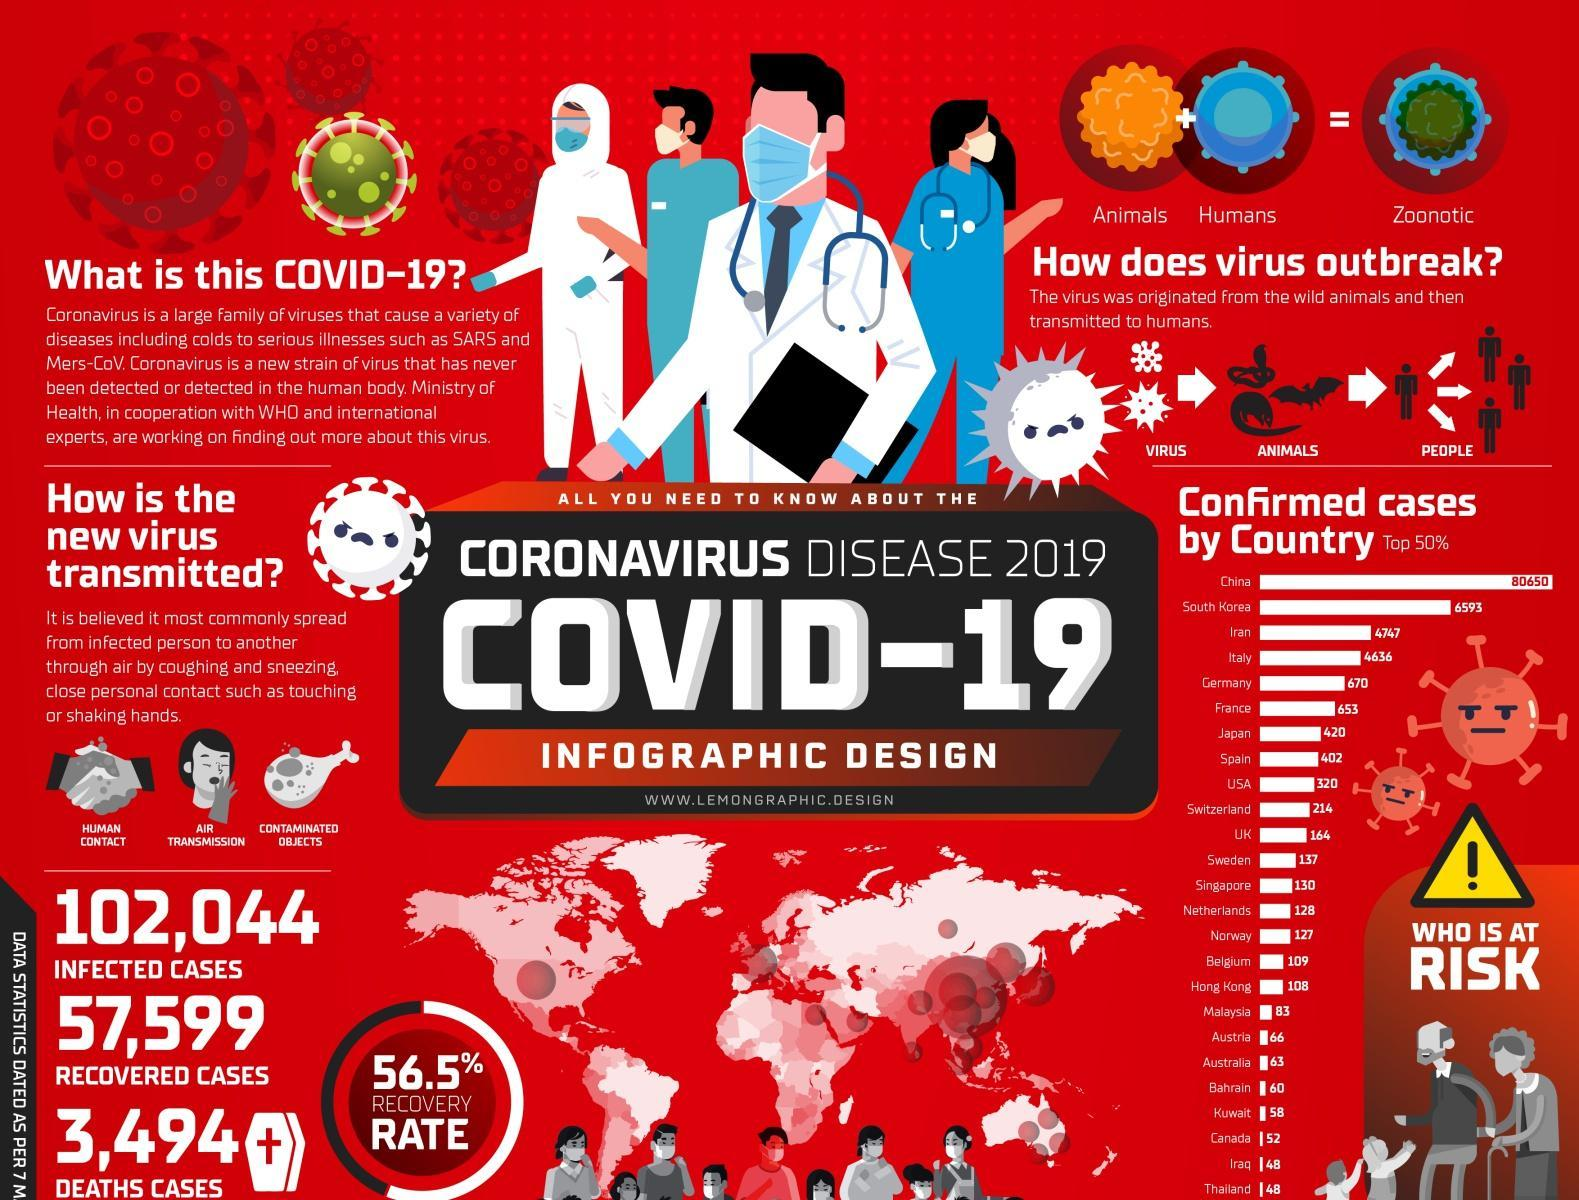What is the number of death cases?
Answer the question with a short phrase. 3,494 What is the percentage of the recovery rate? 56.5% What is the number of infected cases? 102,044 What are the 3 ways in which viruses are transmitted? Human contact, Air transmission, Contaminated Objects What is the number of recovered cases? 57,599 